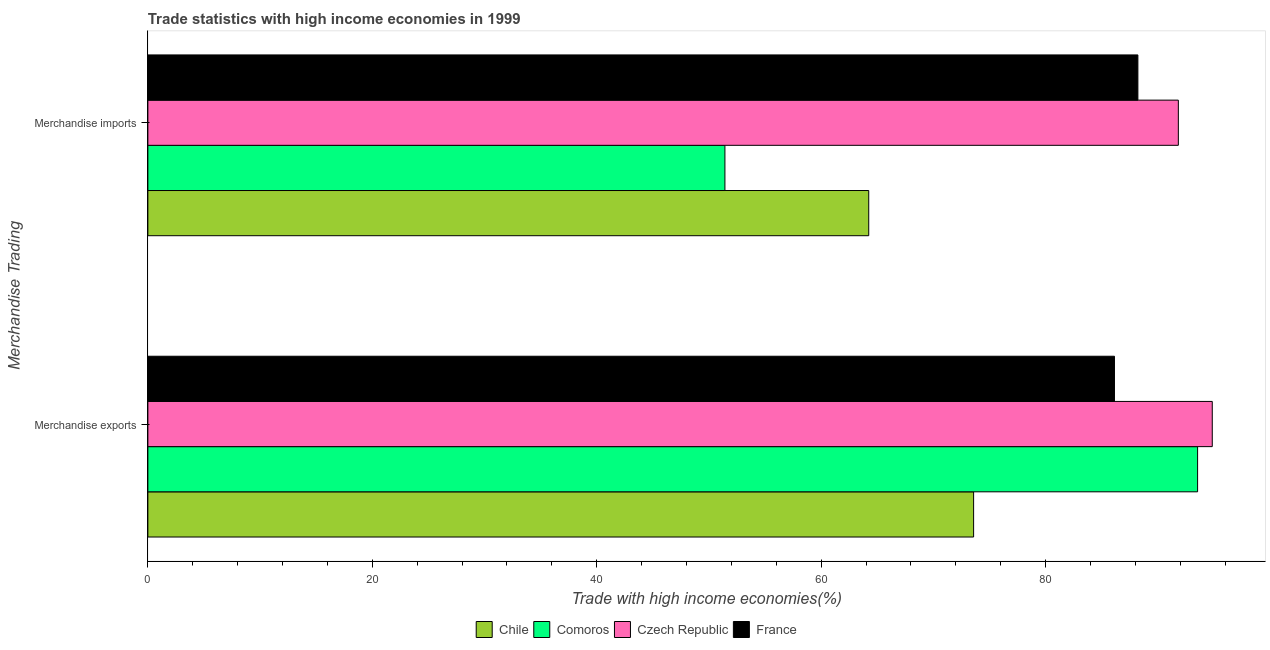How many different coloured bars are there?
Give a very brief answer. 4. Are the number of bars on each tick of the Y-axis equal?
Make the answer very short. Yes. How many bars are there on the 1st tick from the bottom?
Ensure brevity in your answer.  4. What is the label of the 2nd group of bars from the top?
Your response must be concise. Merchandise exports. What is the merchandise imports in France?
Provide a short and direct response. 88.23. Across all countries, what is the maximum merchandise exports?
Your answer should be compact. 94.85. Across all countries, what is the minimum merchandise exports?
Provide a succinct answer. 73.59. In which country was the merchandise imports maximum?
Offer a terse response. Czech Republic. What is the total merchandise exports in the graph?
Keep it short and to the point. 348.13. What is the difference between the merchandise exports in Comoros and that in Chile?
Your answer should be very brief. 19.96. What is the difference between the merchandise exports in Chile and the merchandise imports in Comoros?
Your answer should be compact. 22.16. What is the average merchandise imports per country?
Make the answer very short. 73.93. What is the difference between the merchandise imports and merchandise exports in Comoros?
Ensure brevity in your answer.  -42.12. What is the ratio of the merchandise imports in France to that in Comoros?
Your answer should be very brief. 1.72. Is the merchandise imports in Chile less than that in France?
Offer a terse response. Yes. In how many countries, is the merchandise exports greater than the average merchandise exports taken over all countries?
Give a very brief answer. 2. What does the 3rd bar from the top in Merchandise exports represents?
Ensure brevity in your answer.  Comoros. How many countries are there in the graph?
Your answer should be compact. 4. What is the difference between two consecutive major ticks on the X-axis?
Keep it short and to the point. 20. Are the values on the major ticks of X-axis written in scientific E-notation?
Offer a terse response. No. Does the graph contain grids?
Your answer should be very brief. No. Where does the legend appear in the graph?
Provide a short and direct response. Bottom center. How many legend labels are there?
Your answer should be compact. 4. What is the title of the graph?
Keep it short and to the point. Trade statistics with high income economies in 1999. What is the label or title of the X-axis?
Keep it short and to the point. Trade with high income economies(%). What is the label or title of the Y-axis?
Your response must be concise. Merchandise Trading. What is the Trade with high income economies(%) of Chile in Merchandise exports?
Your answer should be compact. 73.59. What is the Trade with high income economies(%) in Comoros in Merchandise exports?
Provide a short and direct response. 93.55. What is the Trade with high income economies(%) in Czech Republic in Merchandise exports?
Provide a short and direct response. 94.85. What is the Trade with high income economies(%) in France in Merchandise exports?
Your response must be concise. 86.14. What is the Trade with high income economies(%) of Chile in Merchandise imports?
Offer a terse response. 64.24. What is the Trade with high income economies(%) in Comoros in Merchandise imports?
Ensure brevity in your answer.  51.42. What is the Trade with high income economies(%) of Czech Republic in Merchandise imports?
Give a very brief answer. 91.83. What is the Trade with high income economies(%) in France in Merchandise imports?
Make the answer very short. 88.23. Across all Merchandise Trading, what is the maximum Trade with high income economies(%) of Chile?
Ensure brevity in your answer.  73.59. Across all Merchandise Trading, what is the maximum Trade with high income economies(%) in Comoros?
Give a very brief answer. 93.55. Across all Merchandise Trading, what is the maximum Trade with high income economies(%) of Czech Republic?
Ensure brevity in your answer.  94.85. Across all Merchandise Trading, what is the maximum Trade with high income economies(%) in France?
Your answer should be very brief. 88.23. Across all Merchandise Trading, what is the minimum Trade with high income economies(%) in Chile?
Ensure brevity in your answer.  64.24. Across all Merchandise Trading, what is the minimum Trade with high income economies(%) of Comoros?
Ensure brevity in your answer.  51.42. Across all Merchandise Trading, what is the minimum Trade with high income economies(%) in Czech Republic?
Your response must be concise. 91.83. Across all Merchandise Trading, what is the minimum Trade with high income economies(%) of France?
Offer a terse response. 86.14. What is the total Trade with high income economies(%) in Chile in the graph?
Give a very brief answer. 137.83. What is the total Trade with high income economies(%) of Comoros in the graph?
Give a very brief answer. 144.97. What is the total Trade with high income economies(%) in Czech Republic in the graph?
Your answer should be compact. 186.69. What is the total Trade with high income economies(%) in France in the graph?
Keep it short and to the point. 174.37. What is the difference between the Trade with high income economies(%) of Chile in Merchandise exports and that in Merchandise imports?
Give a very brief answer. 9.35. What is the difference between the Trade with high income economies(%) of Comoros in Merchandise exports and that in Merchandise imports?
Offer a terse response. 42.12. What is the difference between the Trade with high income economies(%) of Czech Republic in Merchandise exports and that in Merchandise imports?
Your answer should be very brief. 3.02. What is the difference between the Trade with high income economies(%) in France in Merchandise exports and that in Merchandise imports?
Offer a terse response. -2.09. What is the difference between the Trade with high income economies(%) of Chile in Merchandise exports and the Trade with high income economies(%) of Comoros in Merchandise imports?
Your answer should be very brief. 22.16. What is the difference between the Trade with high income economies(%) in Chile in Merchandise exports and the Trade with high income economies(%) in Czech Republic in Merchandise imports?
Give a very brief answer. -18.24. What is the difference between the Trade with high income economies(%) of Chile in Merchandise exports and the Trade with high income economies(%) of France in Merchandise imports?
Your answer should be very brief. -14.64. What is the difference between the Trade with high income economies(%) of Comoros in Merchandise exports and the Trade with high income economies(%) of Czech Republic in Merchandise imports?
Offer a terse response. 1.71. What is the difference between the Trade with high income economies(%) of Comoros in Merchandise exports and the Trade with high income economies(%) of France in Merchandise imports?
Keep it short and to the point. 5.32. What is the difference between the Trade with high income economies(%) in Czech Republic in Merchandise exports and the Trade with high income economies(%) in France in Merchandise imports?
Make the answer very short. 6.63. What is the average Trade with high income economies(%) in Chile per Merchandise Trading?
Your response must be concise. 68.91. What is the average Trade with high income economies(%) of Comoros per Merchandise Trading?
Ensure brevity in your answer.  72.48. What is the average Trade with high income economies(%) of Czech Republic per Merchandise Trading?
Keep it short and to the point. 93.34. What is the average Trade with high income economies(%) in France per Merchandise Trading?
Provide a succinct answer. 87.18. What is the difference between the Trade with high income economies(%) in Chile and Trade with high income economies(%) in Comoros in Merchandise exports?
Keep it short and to the point. -19.96. What is the difference between the Trade with high income economies(%) of Chile and Trade with high income economies(%) of Czech Republic in Merchandise exports?
Ensure brevity in your answer.  -21.27. What is the difference between the Trade with high income economies(%) of Chile and Trade with high income economies(%) of France in Merchandise exports?
Offer a very short reply. -12.55. What is the difference between the Trade with high income economies(%) in Comoros and Trade with high income economies(%) in Czech Republic in Merchandise exports?
Give a very brief answer. -1.31. What is the difference between the Trade with high income economies(%) in Comoros and Trade with high income economies(%) in France in Merchandise exports?
Keep it short and to the point. 7.41. What is the difference between the Trade with high income economies(%) in Czech Republic and Trade with high income economies(%) in France in Merchandise exports?
Ensure brevity in your answer.  8.72. What is the difference between the Trade with high income economies(%) in Chile and Trade with high income economies(%) in Comoros in Merchandise imports?
Your answer should be very brief. 12.82. What is the difference between the Trade with high income economies(%) of Chile and Trade with high income economies(%) of Czech Republic in Merchandise imports?
Ensure brevity in your answer.  -27.59. What is the difference between the Trade with high income economies(%) of Chile and Trade with high income economies(%) of France in Merchandise imports?
Keep it short and to the point. -23.99. What is the difference between the Trade with high income economies(%) of Comoros and Trade with high income economies(%) of Czech Republic in Merchandise imports?
Give a very brief answer. -40.41. What is the difference between the Trade with high income economies(%) in Comoros and Trade with high income economies(%) in France in Merchandise imports?
Keep it short and to the point. -36.8. What is the difference between the Trade with high income economies(%) of Czech Republic and Trade with high income economies(%) of France in Merchandise imports?
Provide a short and direct response. 3.6. What is the ratio of the Trade with high income economies(%) in Chile in Merchandise exports to that in Merchandise imports?
Provide a succinct answer. 1.15. What is the ratio of the Trade with high income economies(%) of Comoros in Merchandise exports to that in Merchandise imports?
Give a very brief answer. 1.82. What is the ratio of the Trade with high income economies(%) of Czech Republic in Merchandise exports to that in Merchandise imports?
Your response must be concise. 1.03. What is the ratio of the Trade with high income economies(%) of France in Merchandise exports to that in Merchandise imports?
Your response must be concise. 0.98. What is the difference between the highest and the second highest Trade with high income economies(%) of Chile?
Make the answer very short. 9.35. What is the difference between the highest and the second highest Trade with high income economies(%) of Comoros?
Your response must be concise. 42.12. What is the difference between the highest and the second highest Trade with high income economies(%) of Czech Republic?
Provide a succinct answer. 3.02. What is the difference between the highest and the second highest Trade with high income economies(%) of France?
Provide a succinct answer. 2.09. What is the difference between the highest and the lowest Trade with high income economies(%) of Chile?
Provide a succinct answer. 9.35. What is the difference between the highest and the lowest Trade with high income economies(%) of Comoros?
Ensure brevity in your answer.  42.12. What is the difference between the highest and the lowest Trade with high income economies(%) of Czech Republic?
Keep it short and to the point. 3.02. What is the difference between the highest and the lowest Trade with high income economies(%) of France?
Offer a terse response. 2.09. 